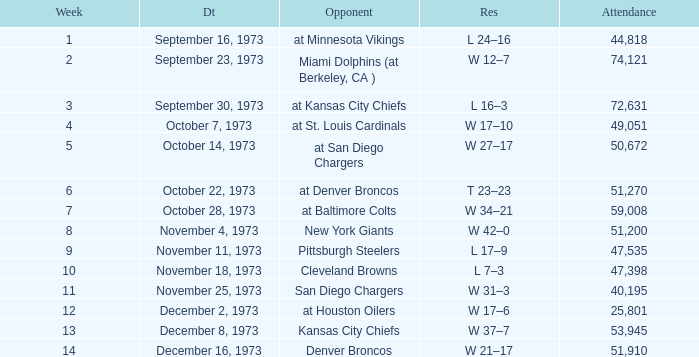What is the attendance for the game against the Kansas City Chiefs earlier than week 13? None. 